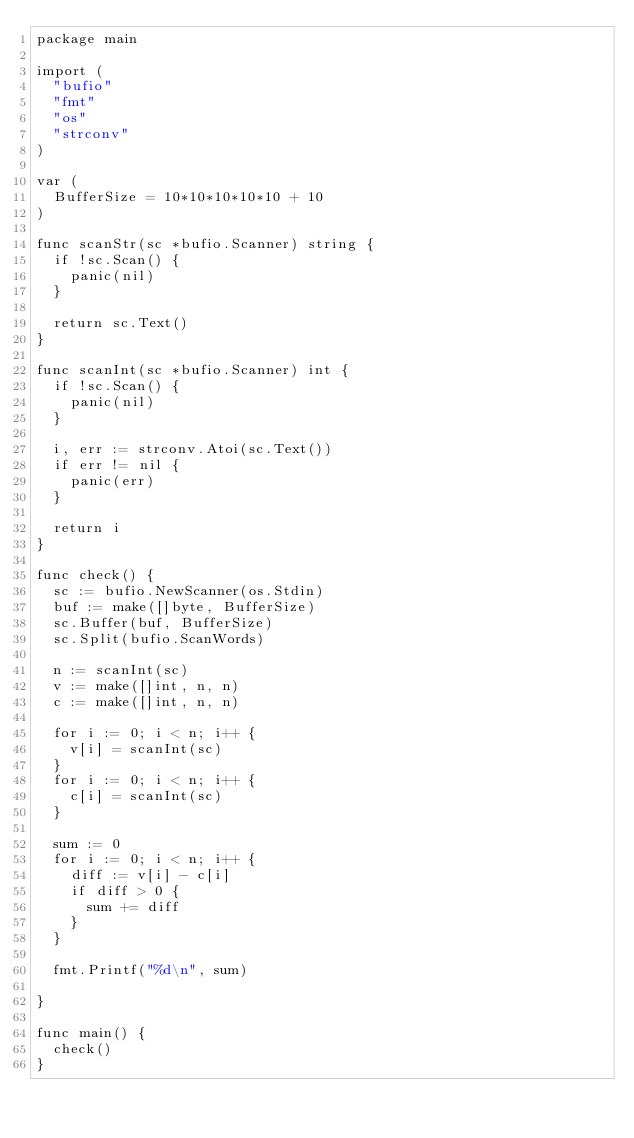<code> <loc_0><loc_0><loc_500><loc_500><_Go_>package main

import (
	"bufio"
	"fmt"
	"os"
	"strconv"
)

var (
	BufferSize = 10*10*10*10*10 + 10
)

func scanStr(sc *bufio.Scanner) string {
	if !sc.Scan() {
		panic(nil)
	}

	return sc.Text()
}

func scanInt(sc *bufio.Scanner) int {
	if !sc.Scan() {
		panic(nil)
	}

	i, err := strconv.Atoi(sc.Text())
	if err != nil {
		panic(err)
	}

	return i
}

func check() {
	sc := bufio.NewScanner(os.Stdin)
	buf := make([]byte, BufferSize)
	sc.Buffer(buf, BufferSize)
	sc.Split(bufio.ScanWords)

	n := scanInt(sc)
	v := make([]int, n, n)
	c := make([]int, n, n)

	for i := 0; i < n; i++ {
		v[i] = scanInt(sc)
	}
	for i := 0; i < n; i++ {
		c[i] = scanInt(sc)
	}

	sum := 0
	for i := 0; i < n; i++ {
		diff := v[i] - c[i]
		if diff > 0 {
			sum += diff
		}
	}

	fmt.Printf("%d\n", sum)

}

func main() {
	check()
}
</code> 